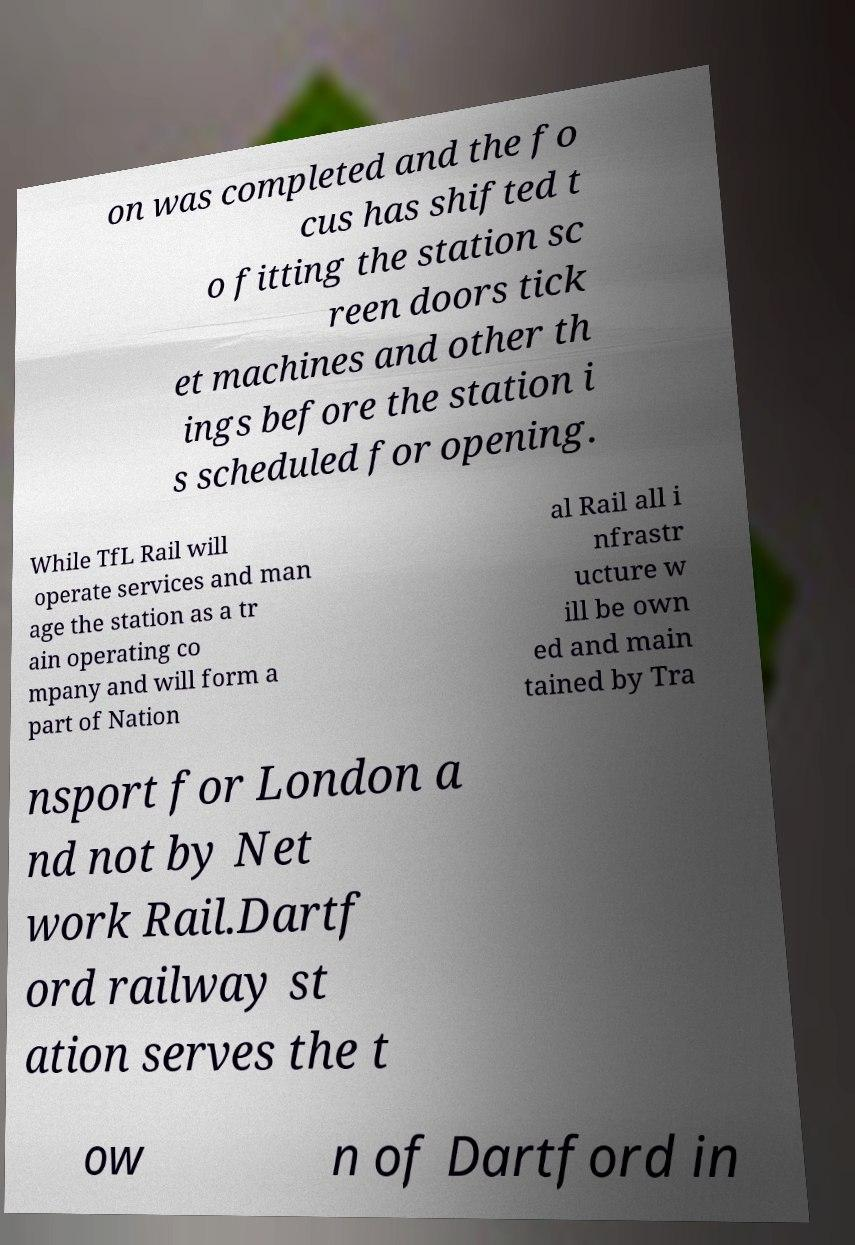Could you extract and type out the text from this image? on was completed and the fo cus has shifted t o fitting the station sc reen doors tick et machines and other th ings before the station i s scheduled for opening. While TfL Rail will operate services and man age the station as a tr ain operating co mpany and will form a part of Nation al Rail all i nfrastr ucture w ill be own ed and main tained by Tra nsport for London a nd not by Net work Rail.Dartf ord railway st ation serves the t ow n of Dartford in 